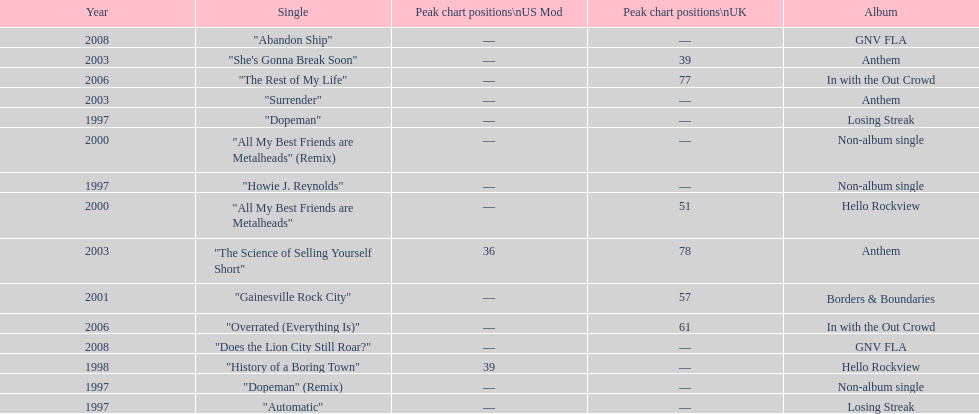Which album had the single automatic? Losing Streak. 